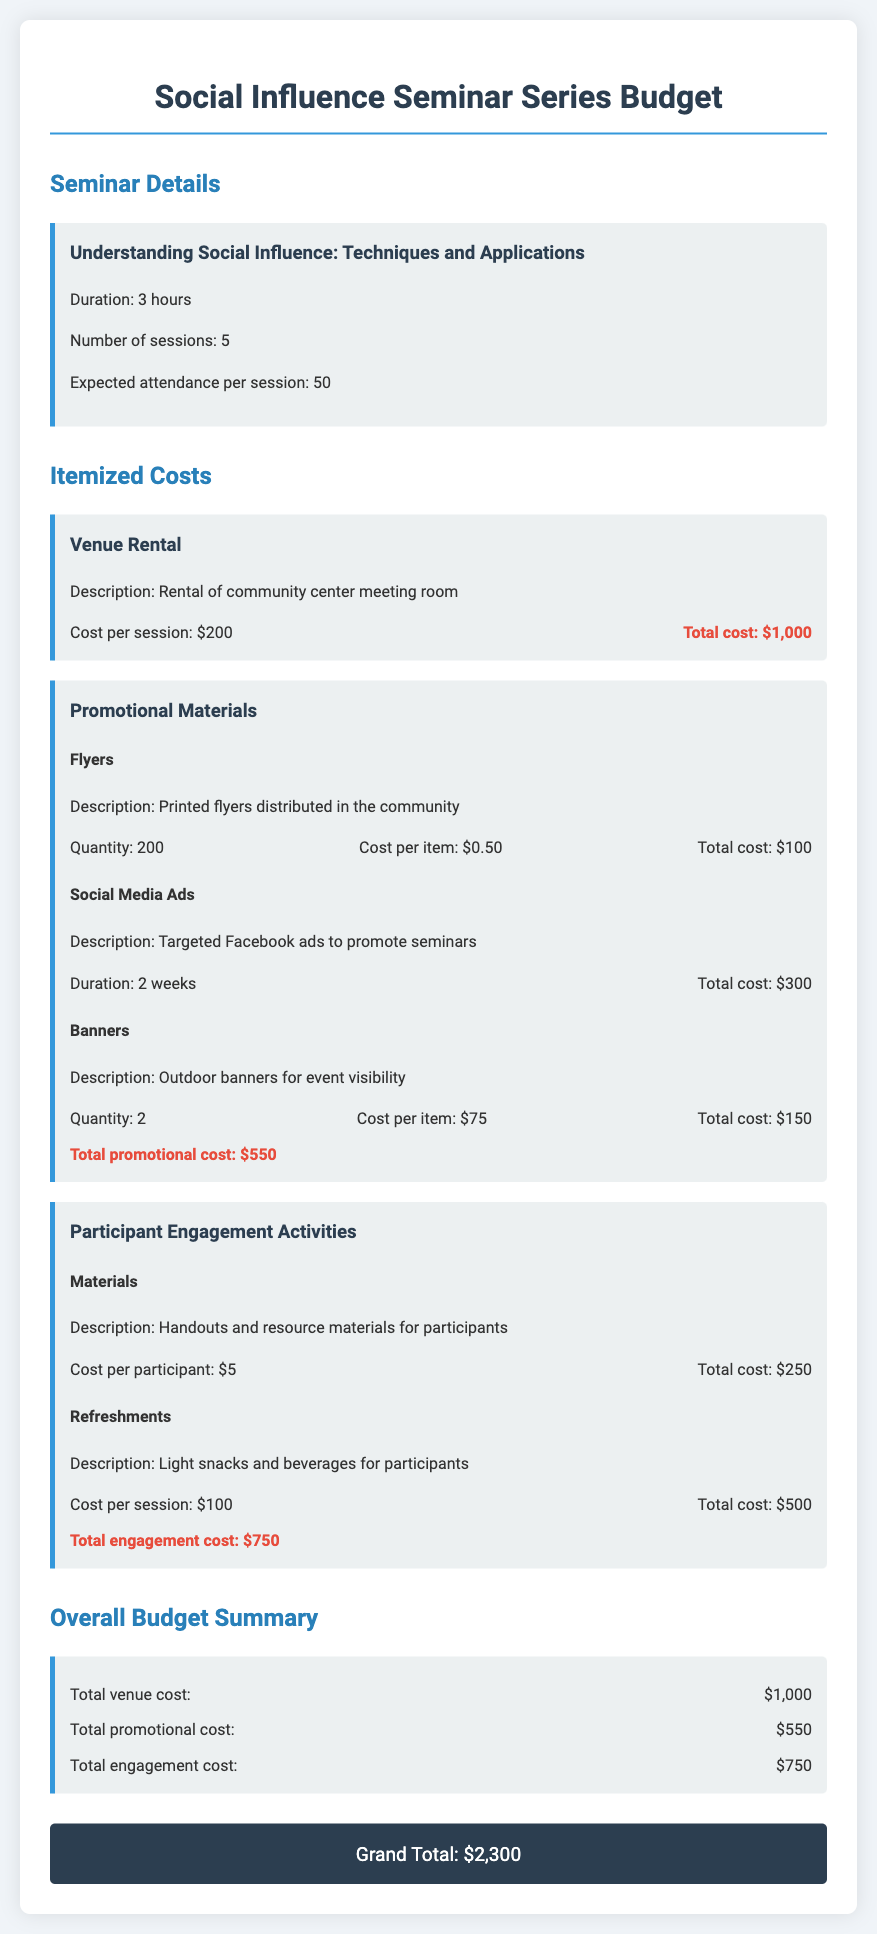What is the title of the seminar series? The title is listed in the seminar details section of the document.
Answer: Understanding Social Influence: Techniques and Applications How many sessions will be conducted? The document specifies the number of sessions in the seminar details.
Answer: 5 What is the cost per session for venue rental? This cost is detailed under the venue rental item in the budget.
Answer: $200 What is the total cost for promotional materials? The total is calculated based on the individual costs of promotional items listed.
Answer: $550 How much will refreshments cost in total? The total is provided in the participant engagement activities section for refreshments.
Answer: $500 What is the cost per participant for materials? This cost is specified under the participant engagement activities in the document.
Answer: $5 What is the grand total for the seminar series budget? The grand total is summarized at the end of the document.
Answer: $2,300 How many expected attendees are there per session? This information is outlined in the seminar details section of the document.
Answer: 50 What is the quantity of printed flyers? The quantity of flyers is specified in the promotional materials section.
Answer: 200 